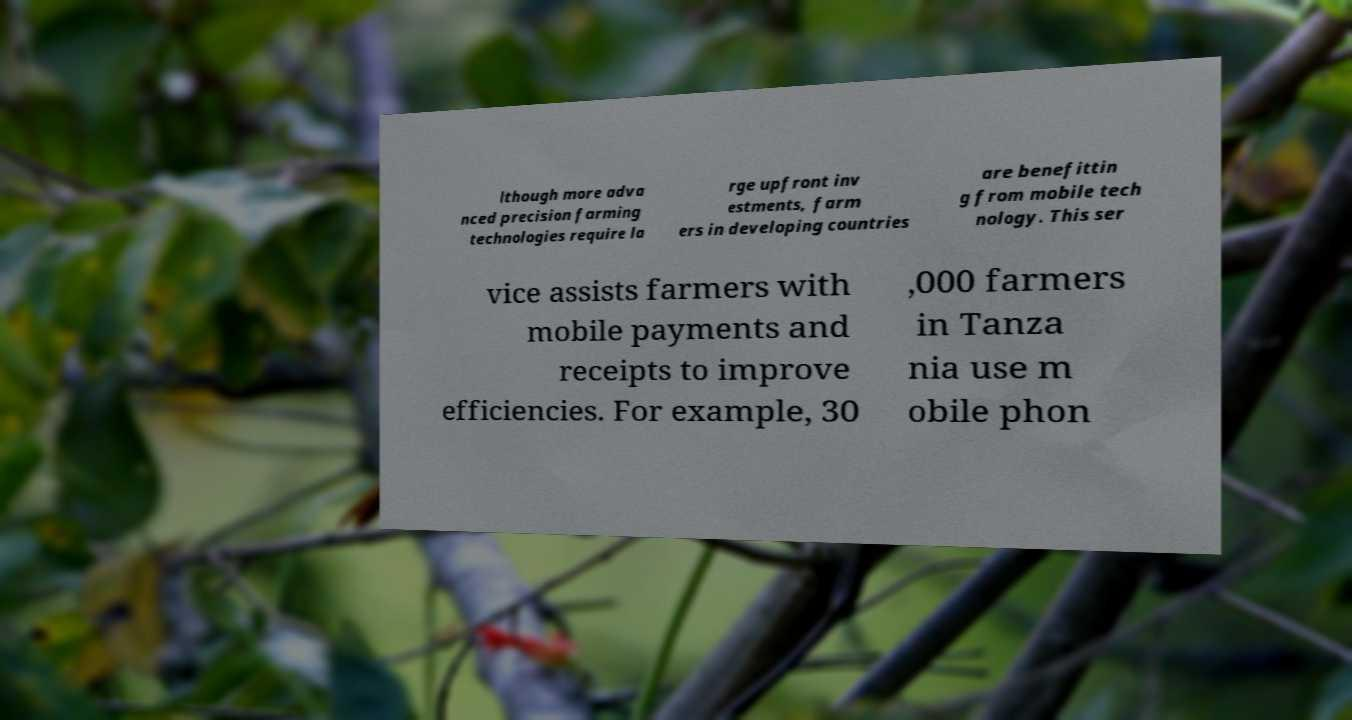For documentation purposes, I need the text within this image transcribed. Could you provide that? lthough more adva nced precision farming technologies require la rge upfront inv estments, farm ers in developing countries are benefittin g from mobile tech nology. This ser vice assists farmers with mobile payments and receipts to improve efficiencies. For example, 30 ,000 farmers in Tanza nia use m obile phon 